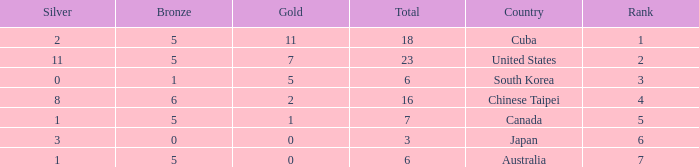What was the sum of the ranks for Japan who had less than 5 bronze medals and more than 3 silvers? None. Could you help me parse every detail presented in this table? {'header': ['Silver', 'Bronze', 'Gold', 'Total', 'Country', 'Rank'], 'rows': [['2', '5', '11', '18', 'Cuba', '1'], ['11', '5', '7', '23', 'United States', '2'], ['0', '1', '5', '6', 'South Korea', '3'], ['8', '6', '2', '16', 'Chinese Taipei', '4'], ['1', '5', '1', '7', 'Canada', '5'], ['3', '0', '0', '3', 'Japan', '6'], ['1', '5', '0', '6', 'Australia', '7']]} 